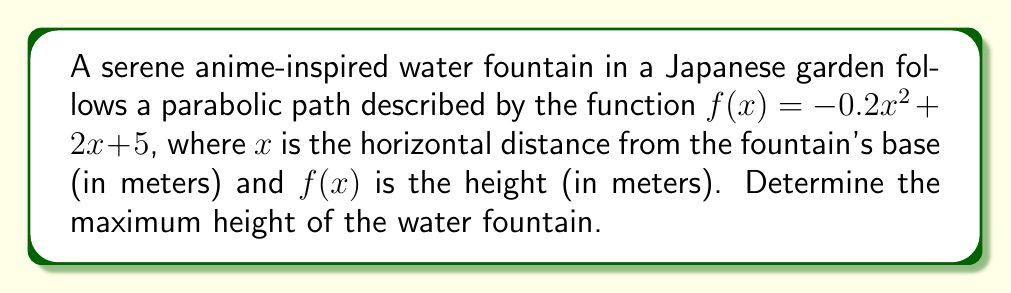Give your solution to this math problem. To find the maximum height of the parabolic water fountain, we need to follow these steps:

1) The given function is a quadratic equation in the form $f(x) = ax^2 + bx + c$, where:
   $a = -0.2$
   $b = 2$
   $c = 5$

2) For a parabola, the maximum (or minimum) point occurs at the vertex. Since $a$ is negative, this parabola opens downward and has a maximum point.

3) To find the x-coordinate of the vertex, we use the formula: $x = -\frac{b}{2a}$

   $x = -\frac{2}{2(-0.2)} = -\frac{2}{-0.4} = 5$

4) To find the maximum height (y-coordinate of the vertex), we substitute this x-value into the original function:

   $f(5) = -0.2(5)^2 + 2(5) + 5$
   $    = -0.2(25) + 10 + 5$
   $    = -5 + 10 + 5$
   $    = 10$

5) Therefore, the maximum height of the water fountain is 10 meters.
Answer: 10 meters 